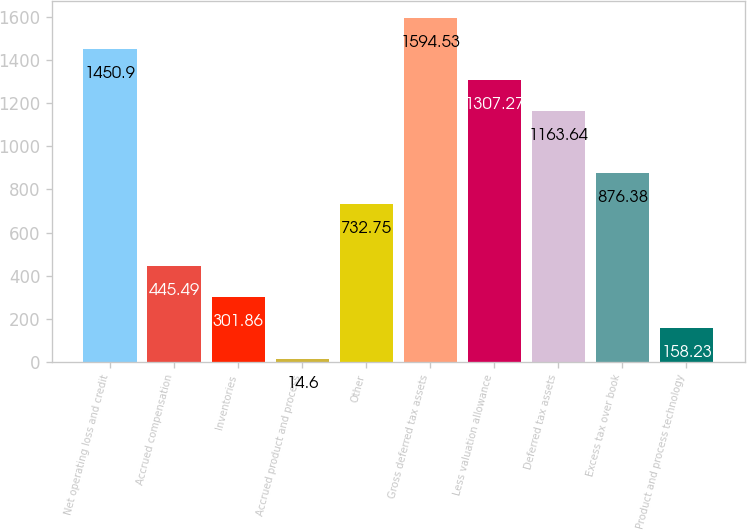<chart> <loc_0><loc_0><loc_500><loc_500><bar_chart><fcel>Net operating loss and credit<fcel>Accrued compensation<fcel>Inventories<fcel>Accrued product and process<fcel>Other<fcel>Gross deferred tax assets<fcel>Less valuation allowance<fcel>Deferred tax assets<fcel>Excess tax over book<fcel>Product and process technology<nl><fcel>1450.9<fcel>445.49<fcel>301.86<fcel>14.6<fcel>732.75<fcel>1594.53<fcel>1307.27<fcel>1163.64<fcel>876.38<fcel>158.23<nl></chart> 